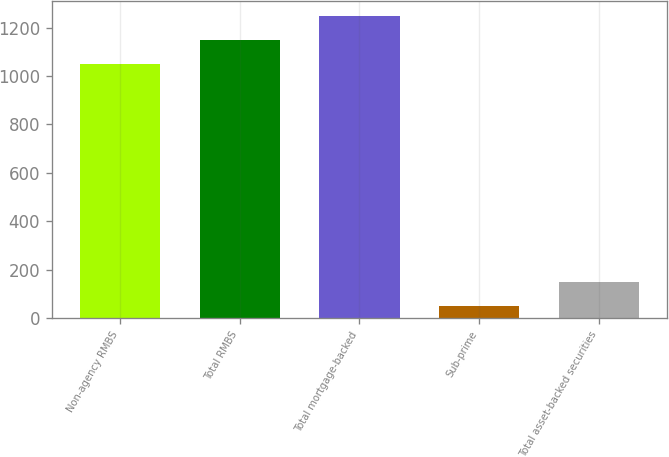Convert chart to OTSL. <chart><loc_0><loc_0><loc_500><loc_500><bar_chart><fcel>Non-agency RMBS<fcel>Total RMBS<fcel>Total mortgage-backed<fcel>Sub-prime<fcel>Total asset-backed securities<nl><fcel>1048<fcel>1147.8<fcel>1247.6<fcel>50<fcel>149.8<nl></chart> 